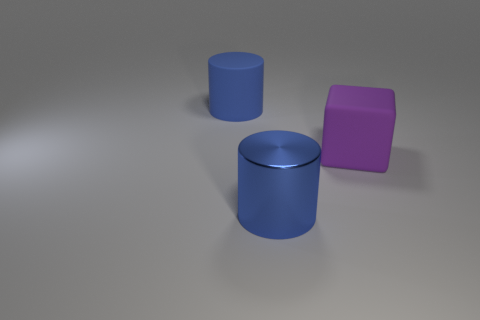Add 1 blocks. How many objects exist? 4 Subtract all cylinders. How many objects are left? 1 Add 2 big blue shiny cylinders. How many big blue shiny cylinders exist? 3 Subtract 0 yellow spheres. How many objects are left? 3 Subtract all yellow cylinders. Subtract all blue cubes. How many cylinders are left? 2 Subtract all green spheres. Subtract all large metallic things. How many objects are left? 2 Add 2 matte cylinders. How many matte cylinders are left? 3 